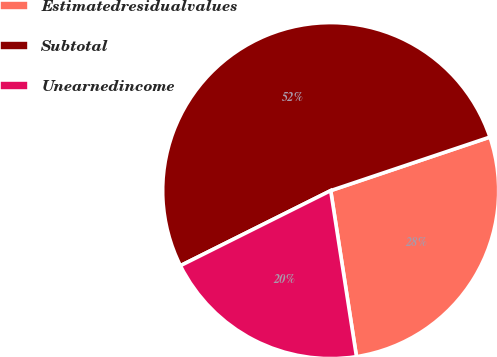Convert chart to OTSL. <chart><loc_0><loc_0><loc_500><loc_500><pie_chart><fcel>Estimatedresidualvalues<fcel>Subtotal<fcel>Unearnedincome<nl><fcel>27.71%<fcel>52.21%<fcel>20.08%<nl></chart> 